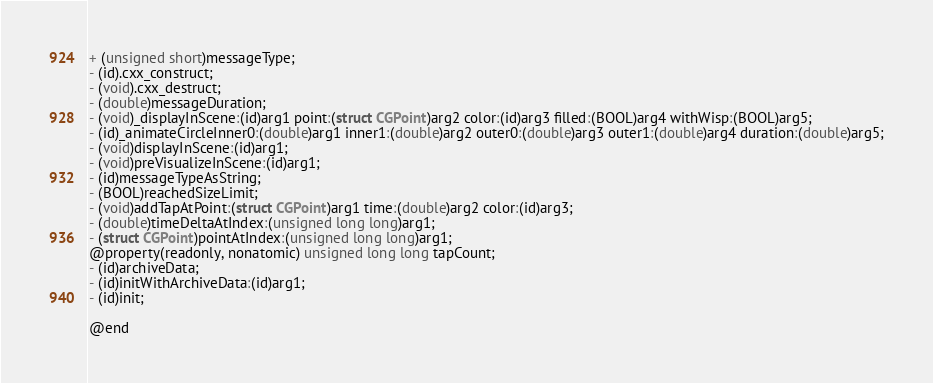<code> <loc_0><loc_0><loc_500><loc_500><_C_>+ (unsigned short)messageType;
- (id).cxx_construct;
- (void).cxx_destruct;
- (double)messageDuration;
- (void)_displayInScene:(id)arg1 point:(struct CGPoint)arg2 color:(id)arg3 filled:(BOOL)arg4 withWisp:(BOOL)arg5;
- (id)_animateCircleInner0:(double)arg1 inner1:(double)arg2 outer0:(double)arg3 outer1:(double)arg4 duration:(double)arg5;
- (void)displayInScene:(id)arg1;
- (void)preVisualizeInScene:(id)arg1;
- (id)messageTypeAsString;
- (BOOL)reachedSizeLimit;
- (void)addTapAtPoint:(struct CGPoint)arg1 time:(double)arg2 color:(id)arg3;
- (double)timeDeltaAtIndex:(unsigned long long)arg1;
- (struct CGPoint)pointAtIndex:(unsigned long long)arg1;
@property(readonly, nonatomic) unsigned long long tapCount;
- (id)archiveData;
- (id)initWithArchiveData:(id)arg1;
- (id)init;

@end

</code> 